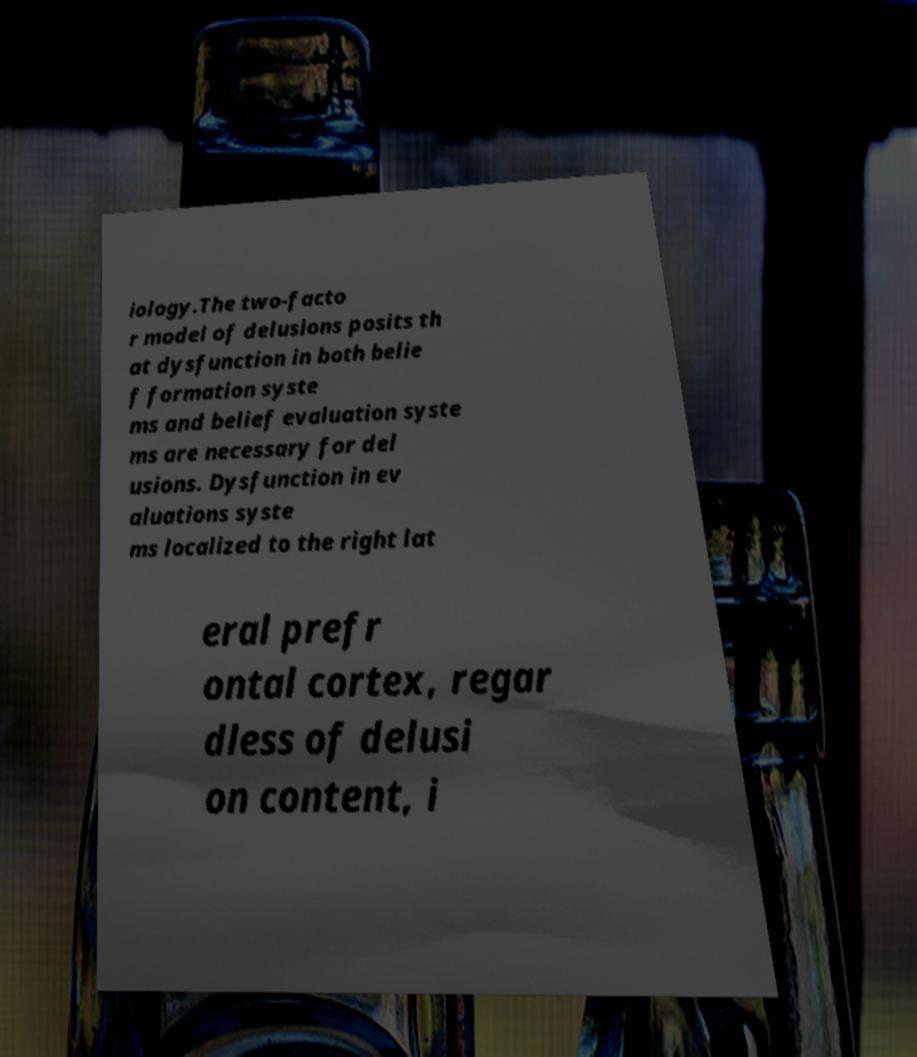Can you accurately transcribe the text from the provided image for me? iology.The two-facto r model of delusions posits th at dysfunction in both belie f formation syste ms and belief evaluation syste ms are necessary for del usions. Dysfunction in ev aluations syste ms localized to the right lat eral prefr ontal cortex, regar dless of delusi on content, i 